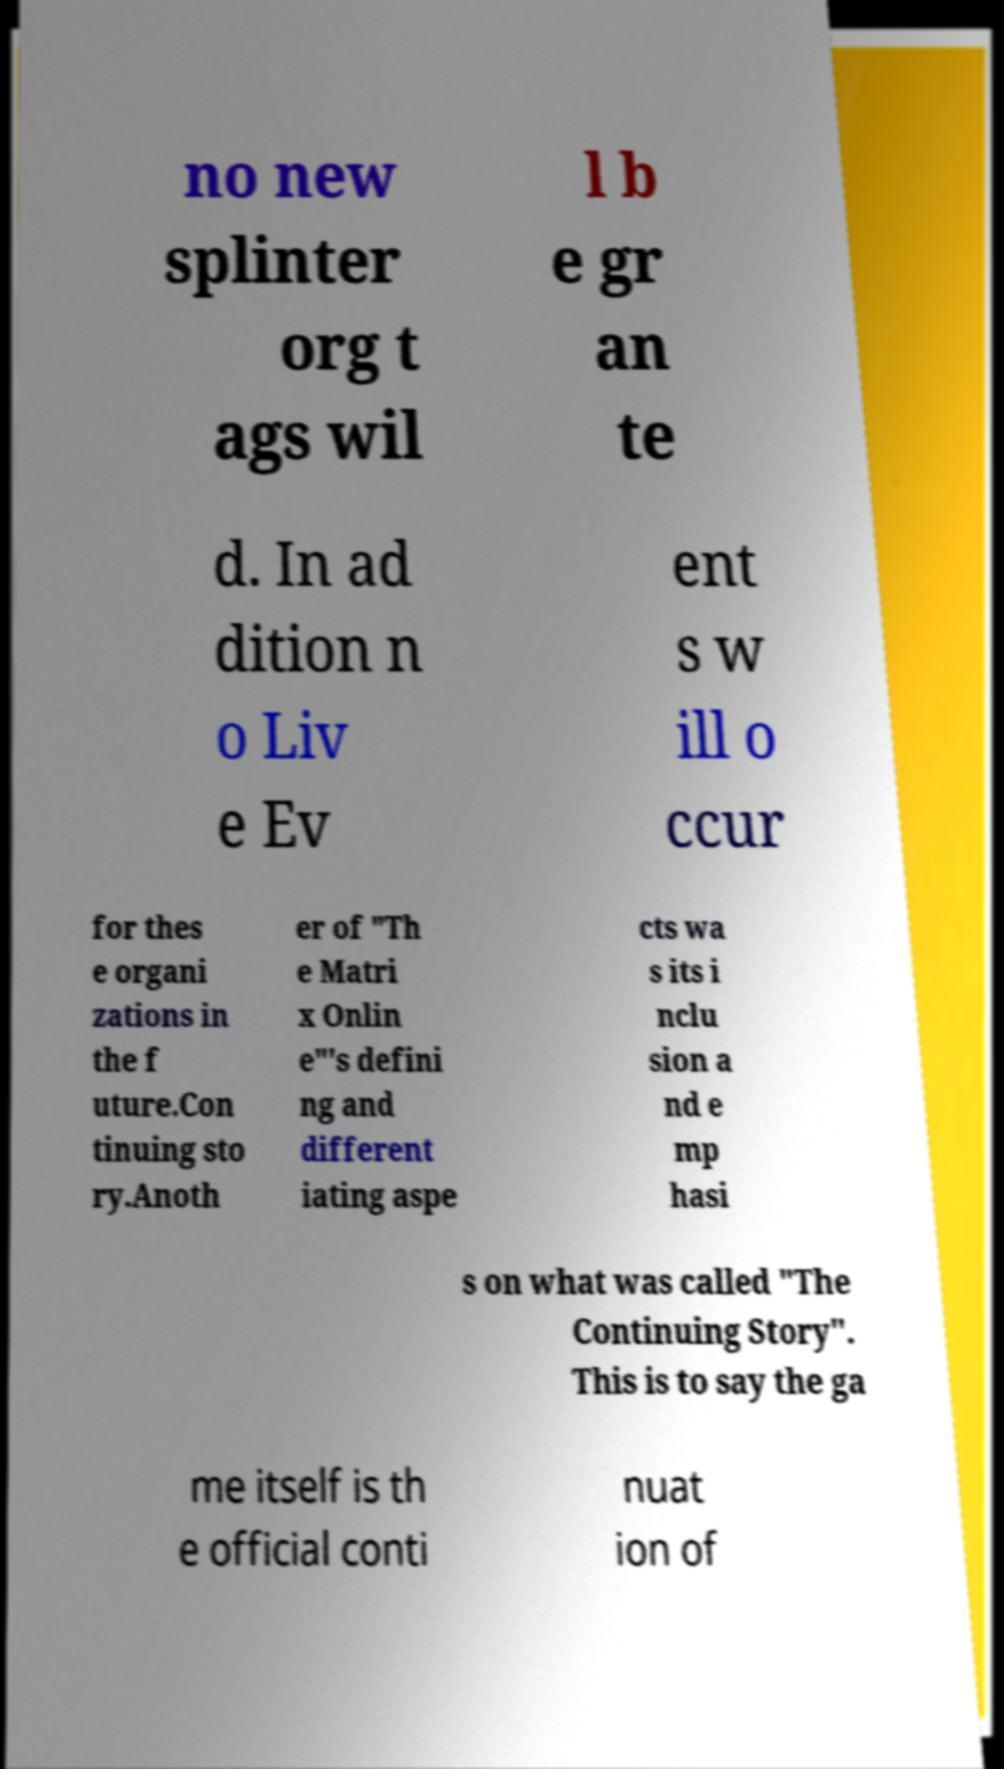Could you extract and type out the text from this image? no new splinter org t ags wil l b e gr an te d. In ad dition n o Liv e Ev ent s w ill o ccur for thes e organi zations in the f uture.Con tinuing sto ry.Anoth er of "Th e Matri x Onlin e"'s defini ng and different iating aspe cts wa s its i nclu sion a nd e mp hasi s on what was called "The Continuing Story". This is to say the ga me itself is th e official conti nuat ion of 